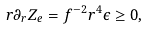<formula> <loc_0><loc_0><loc_500><loc_500>r \partial _ { r } Z _ { e } = f ^ { - 2 } r ^ { 4 } \epsilon \geq 0 ,</formula> 